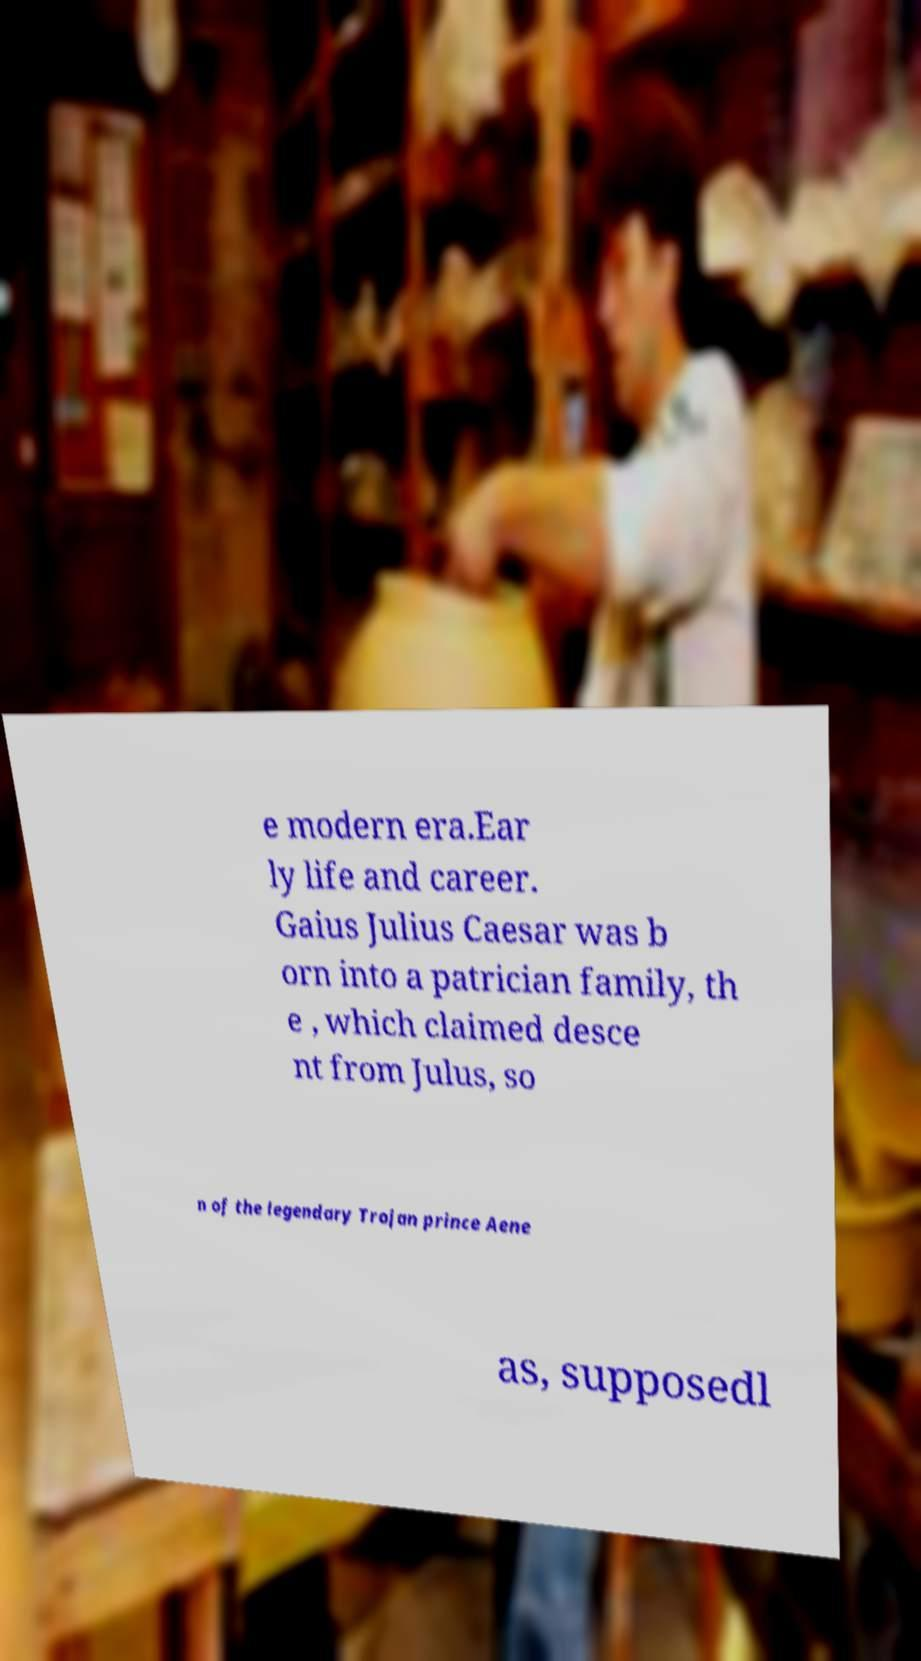Please identify and transcribe the text found in this image. e modern era.Ear ly life and career. Gaius Julius Caesar was b orn into a patrician family, th e , which claimed desce nt from Julus, so n of the legendary Trojan prince Aene as, supposedl 